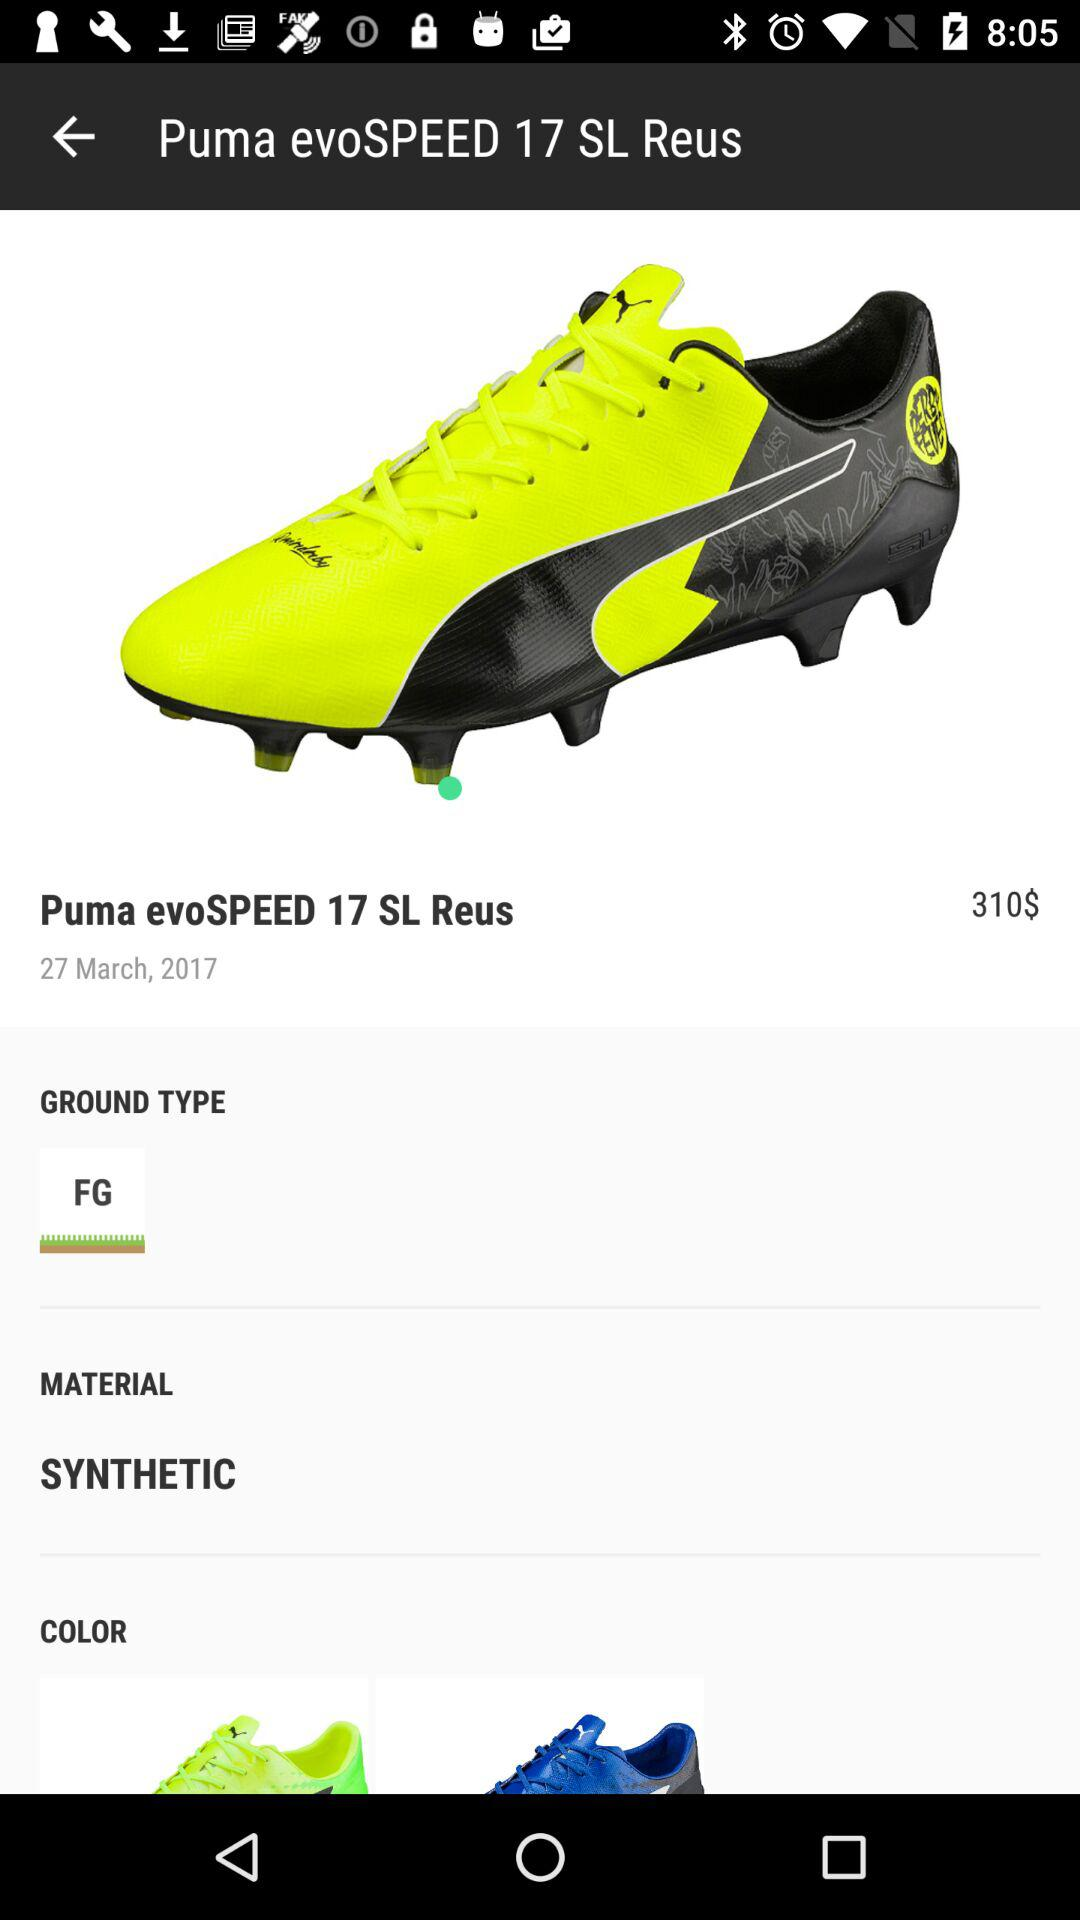What is the material of the shoe? The material of the shoe is synthetic. 